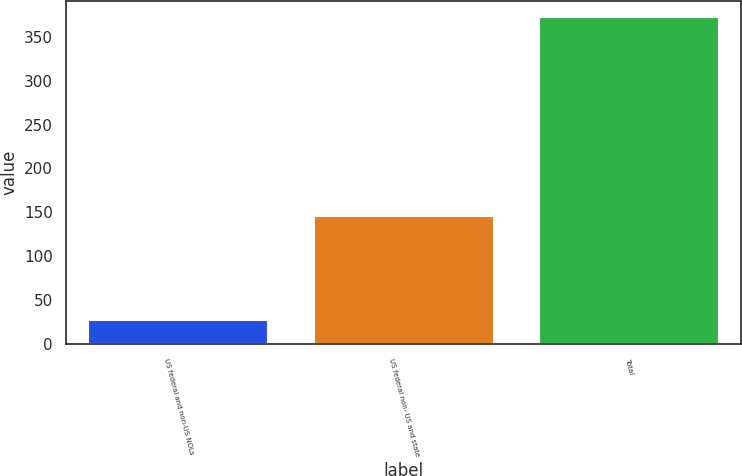Convert chart to OTSL. <chart><loc_0><loc_0><loc_500><loc_500><bar_chart><fcel>US federal and non-US NOLs<fcel>US federal non- US and state<fcel>Total<nl><fcel>28<fcel>146<fcel>372<nl></chart> 